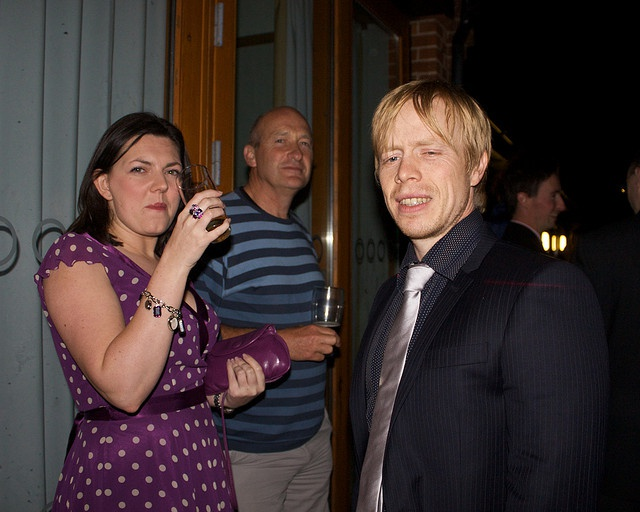Describe the objects in this image and their specific colors. I can see people in purple, black, tan, and gray tones, people in purple, black, and salmon tones, people in purple, black, gray, and maroon tones, tie in purple, gray, lightgray, black, and darkgray tones, and people in purple, black, maroon, white, and brown tones in this image. 